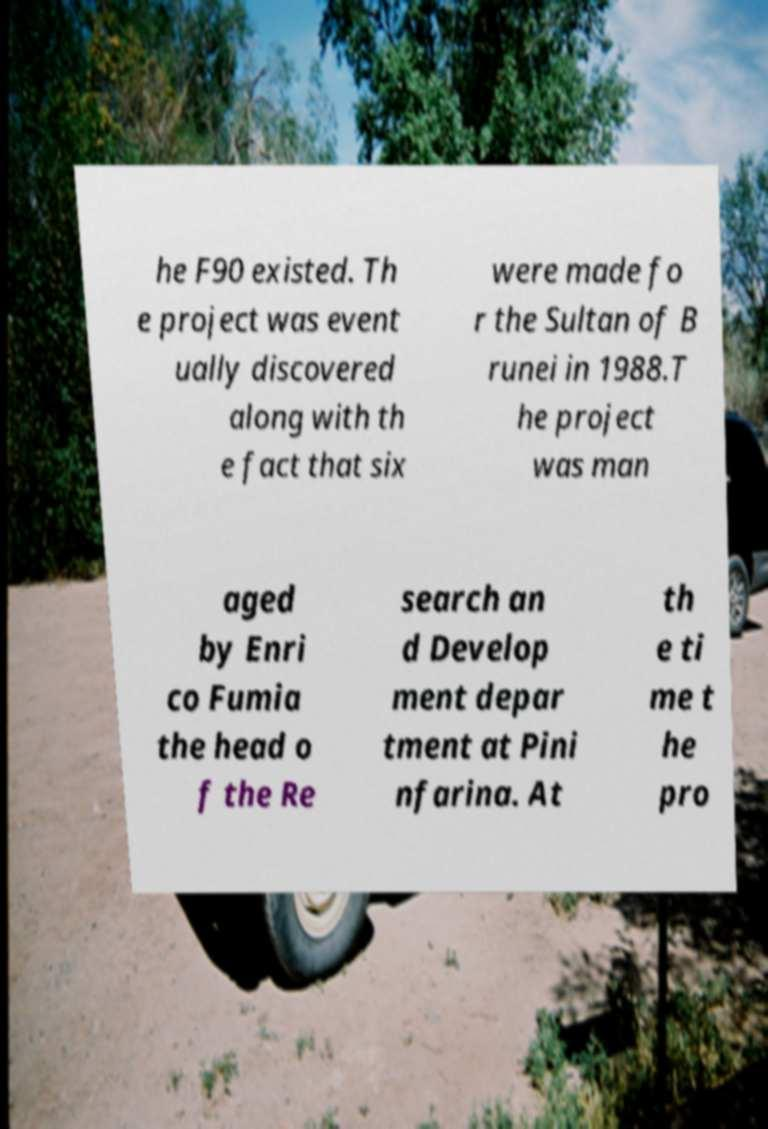Please read and relay the text visible in this image. What does it say? he F90 existed. Th e project was event ually discovered along with th e fact that six were made fo r the Sultan of B runei in 1988.T he project was man aged by Enri co Fumia the head o f the Re search an d Develop ment depar tment at Pini nfarina. At th e ti me t he pro 